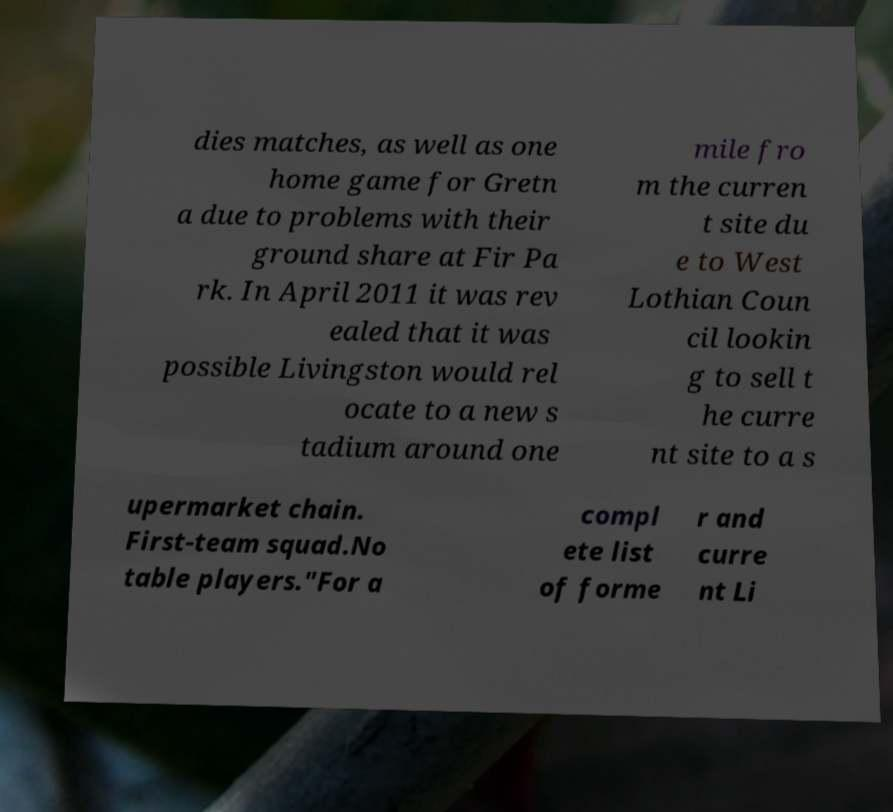Please read and relay the text visible in this image. What does it say? dies matches, as well as one home game for Gretn a due to problems with their ground share at Fir Pa rk. In April 2011 it was rev ealed that it was possible Livingston would rel ocate to a new s tadium around one mile fro m the curren t site du e to West Lothian Coun cil lookin g to sell t he curre nt site to a s upermarket chain. First-team squad.No table players."For a compl ete list of forme r and curre nt Li 